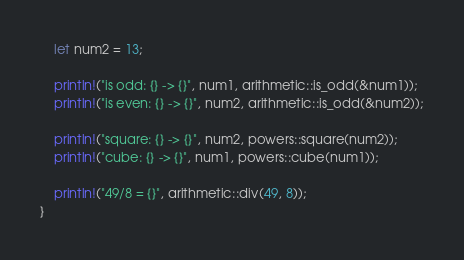<code> <loc_0><loc_0><loc_500><loc_500><_Rust_>    let num2 = 13;

    println!("is odd: {} -> {}", num1, arithmetic::is_odd(&num1));
    println!("is even: {} -> {}", num2, arithmetic::is_odd(&num2));

    println!("square: {} -> {}", num2, powers::square(num2));
    println!("cube: {} -> {}", num1, powers::cube(num1));

    println!("49/8 = {}", arithmetic::div(49, 8));
}
</code> 